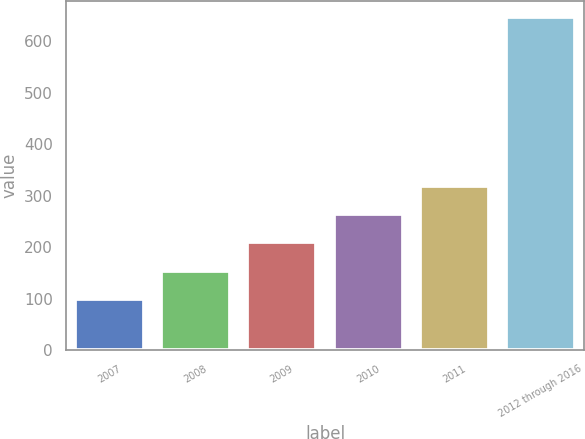<chart> <loc_0><loc_0><loc_500><loc_500><bar_chart><fcel>2007<fcel>2008<fcel>2009<fcel>2010<fcel>2011<fcel>2012 through 2016<nl><fcel>100<fcel>154.6<fcel>209.2<fcel>263.8<fcel>318.4<fcel>646<nl></chart> 